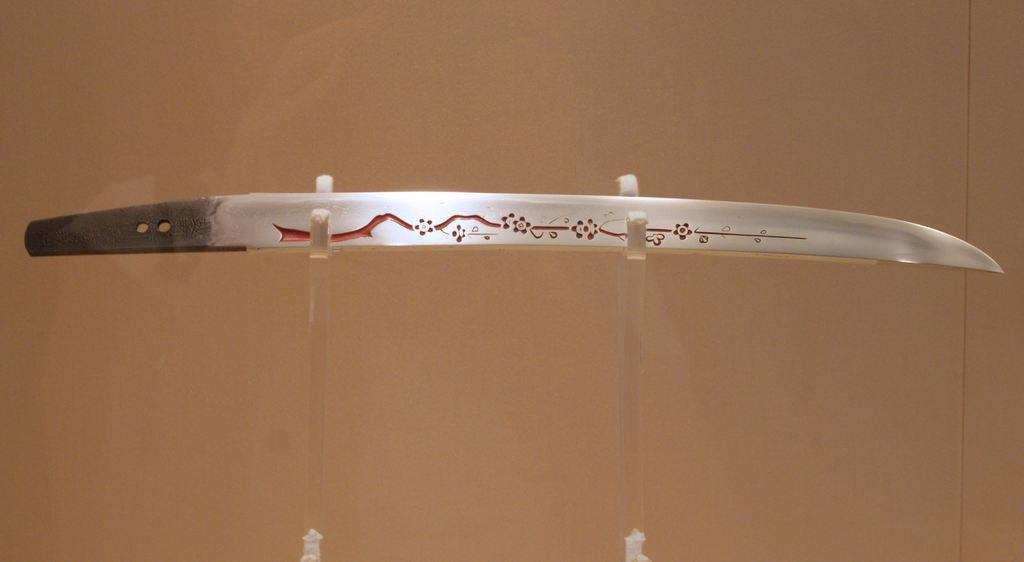What is the main object in the center of the image? There is a sword in the center of the image. Can you describe the sword in more detail? Unfortunately, the facts provided do not give any additional details about the sword. Is there anything else in the image besides the sword? The facts provided do not mention any other objects or elements in the image. What type of cannon is being sold at the store in the image? There is no cannon or store present in the image; it only features a sword in the center. 